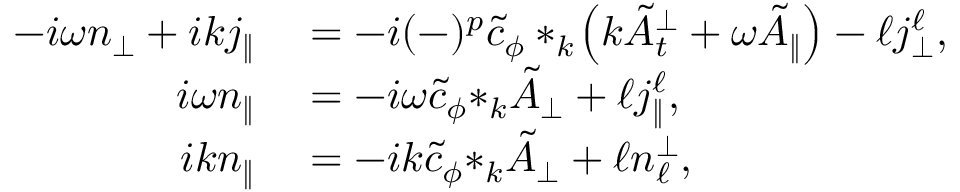<formula> <loc_0><loc_0><loc_500><loc_500>\begin{array} { r l } { - i \omega { n _ { \perp } } + i k { j _ { \| } } } & = - i ( - ) ^ { p } \tilde { c } _ { \phi } * _ { k } \, \left ( k \tilde { A } _ { t } ^ { \perp } + \omega \tilde { A } _ { \| } \right ) - \ell { j _ { \perp } ^ { \ell } } , } \\ { i \omega { n } _ { \| } } & = - i \omega \tilde { c } _ { \phi } { * _ { k } \tilde { A } _ { \perp } } + \ell j _ { \| } ^ { \ell } , } \\ { i k { n _ { \| } } } & = - i k \tilde { c } _ { \phi } { * _ { k } \tilde { A } _ { \perp } } + \ell { n _ { \ell } ^ { \perp } } , } \end{array}</formula> 